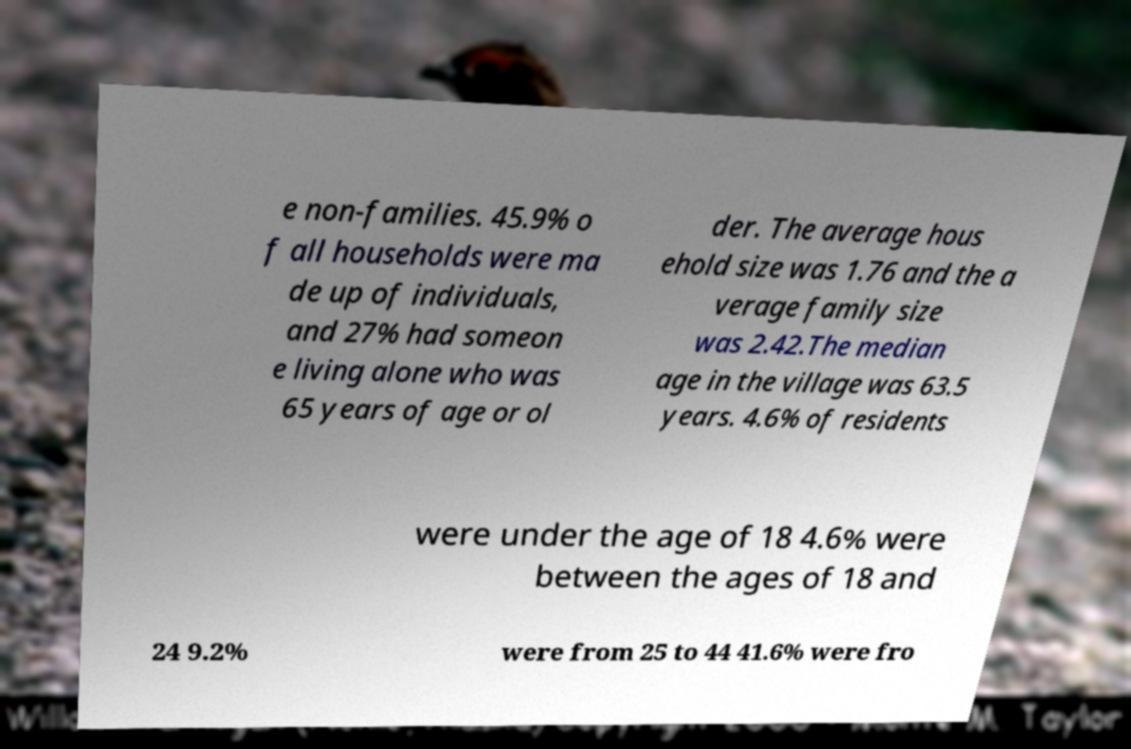Can you read and provide the text displayed in the image?This photo seems to have some interesting text. Can you extract and type it out for me? e non-families. 45.9% o f all households were ma de up of individuals, and 27% had someon e living alone who was 65 years of age or ol der. The average hous ehold size was 1.76 and the a verage family size was 2.42.The median age in the village was 63.5 years. 4.6% of residents were under the age of 18 4.6% were between the ages of 18 and 24 9.2% were from 25 to 44 41.6% were fro 